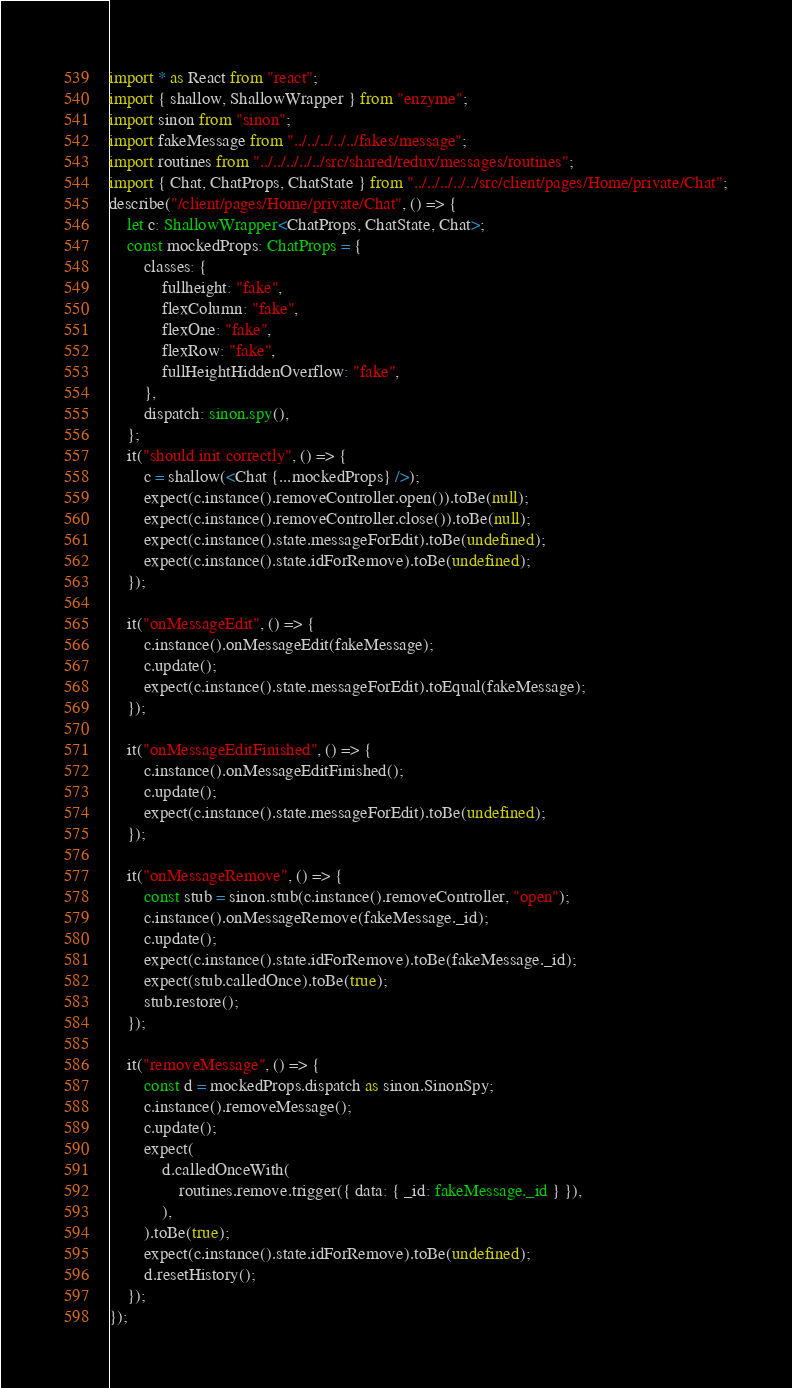Convert code to text. <code><loc_0><loc_0><loc_500><loc_500><_TypeScript_>import * as React from "react";
import { shallow, ShallowWrapper } from "enzyme";
import sinon from "sinon";
import fakeMessage from "../../../../../fakes/message";
import routines from "../../../../../src/shared/redux/messages/routines";
import { Chat, ChatProps, ChatState } from "../../../../../src/client/pages/Home/private/Chat";
describe("/client/pages/Home/private/Chat", () => {
	let c: ShallowWrapper<ChatProps, ChatState, Chat>;
	const mockedProps: ChatProps = {
		classes: {
			fullheight: "fake",
			flexColumn: "fake",
			flexOne: "fake",
			flexRow: "fake",
			fullHeightHiddenOverflow: "fake",
		},
		dispatch: sinon.spy(),
	};
	it("should init correctly", () => {
		c = shallow(<Chat {...mockedProps} />);
		expect(c.instance().removeController.open()).toBe(null);
		expect(c.instance().removeController.close()).toBe(null);
		expect(c.instance().state.messageForEdit).toBe(undefined);
		expect(c.instance().state.idForRemove).toBe(undefined);
	});

	it("onMessageEdit", () => {
		c.instance().onMessageEdit(fakeMessage);
		c.update();
		expect(c.instance().state.messageForEdit).toEqual(fakeMessage);
	});

	it("onMessageEditFinished", () => {
		c.instance().onMessageEditFinished();
		c.update();
		expect(c.instance().state.messageForEdit).toBe(undefined);
	});

	it("onMessageRemove", () => {
		const stub = sinon.stub(c.instance().removeController, "open");
		c.instance().onMessageRemove(fakeMessage._id);
		c.update();
		expect(c.instance().state.idForRemove).toBe(fakeMessage._id);
		expect(stub.calledOnce).toBe(true);
		stub.restore();
	});

	it("removeMessage", () => {
		const d = mockedProps.dispatch as sinon.SinonSpy;
		c.instance().removeMessage();
		c.update();
		expect(
			d.calledOnceWith(
				routines.remove.trigger({ data: { _id: fakeMessage._id } }),
			),
		).toBe(true);
		expect(c.instance().state.idForRemove).toBe(undefined);
		d.resetHistory();
	});
});</code> 